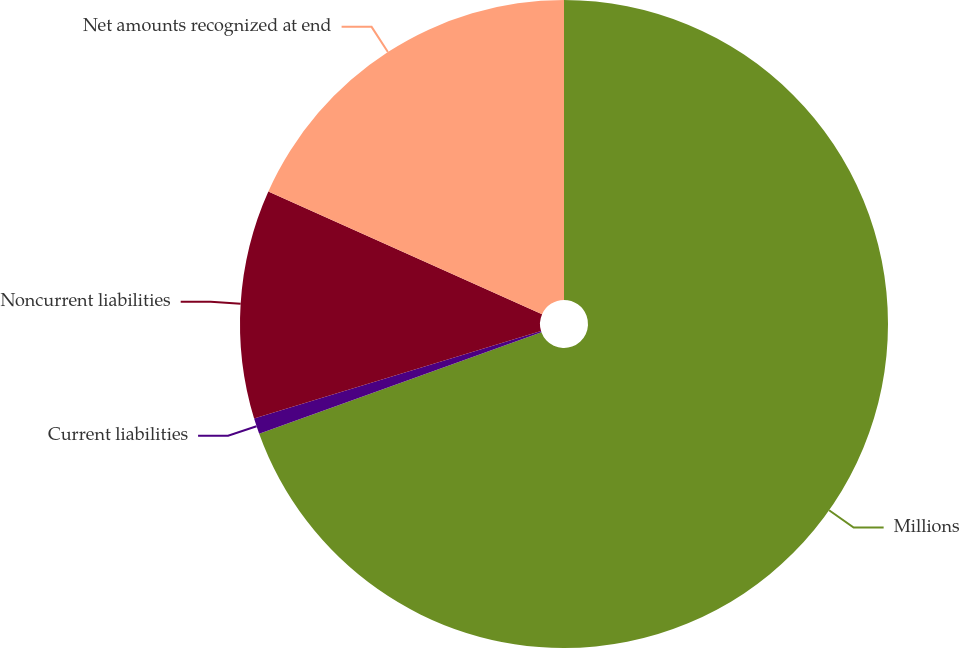Convert chart to OTSL. <chart><loc_0><loc_0><loc_500><loc_500><pie_chart><fcel>Millions<fcel>Current liabilities<fcel>Noncurrent liabilities<fcel>Net amounts recognized at end<nl><fcel>69.49%<fcel>0.79%<fcel>11.42%<fcel>18.29%<nl></chart> 